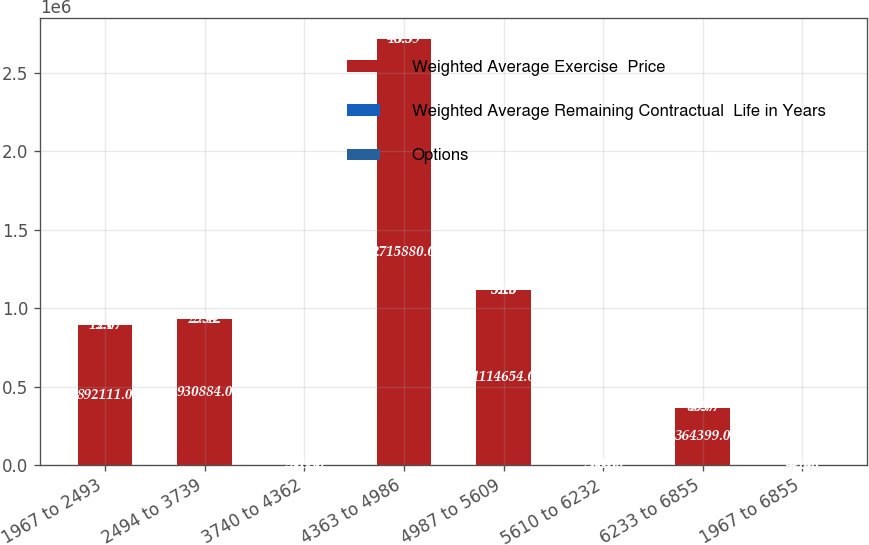Convert chart. <chart><loc_0><loc_0><loc_500><loc_500><stacked_bar_chart><ecel><fcel>1967 to 2493<fcel>2494 to 3739<fcel>3740 to 4362<fcel>4363 to 4986<fcel>4987 to 5609<fcel>5610 to 6232<fcel>6233 to 6855<fcel>1967 to 6855<nl><fcel>Weighted Average Exercise  Price<fcel>892111<fcel>930884<fcel>2412<fcel>2.71588e+06<fcel>1.11465e+06<fcel>2761<fcel>364399<fcel>42.05<nl><fcel>Weighted Average Remaining Contractual  Life in Years<fcel>2.1<fcel>2.54<fcel>3.83<fcel>5.5<fcel>5.16<fcel>8.48<fcel>8.57<fcel>4.66<nl><fcel>Options<fcel>19.67<fcel>29.42<fcel>41.44<fcel>46.59<fcel>51.3<fcel>60.8<fcel>66.77<fcel>42.05<nl></chart> 